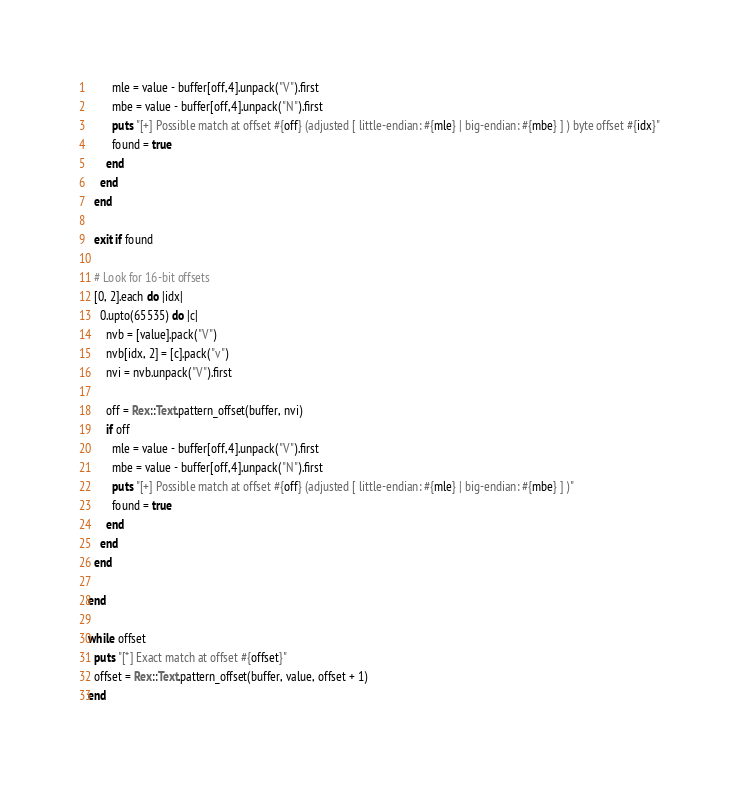Convert code to text. <code><loc_0><loc_0><loc_500><loc_500><_Ruby_>        mle = value - buffer[off,4].unpack("V").first
        mbe = value - buffer[off,4].unpack("N").first
        puts "[+] Possible match at offset #{off} (adjusted [ little-endian: #{mle} | big-endian: #{mbe} ] ) byte offset #{idx}"
        found = true
      end
    end
  end

  exit if found

  # Look for 16-bit offsets
  [0, 2].each do |idx|
    0.upto(65535) do |c|
      nvb = [value].pack("V")
      nvb[idx, 2] = [c].pack("v")
      nvi = nvb.unpack("V").first

      off = Rex::Text.pattern_offset(buffer, nvi)
      if off
        mle = value - buffer[off,4].unpack("V").first
        mbe = value - buffer[off,4].unpack("N").first
        puts "[+] Possible match at offset #{off} (adjusted [ little-endian: #{mle} | big-endian: #{mbe} ] )"
        found = true
      end
    end
  end

end

while offset
  puts "[*] Exact match at offset #{offset}"
  offset = Rex::Text.pattern_offset(buffer, value, offset + 1)
end
</code> 